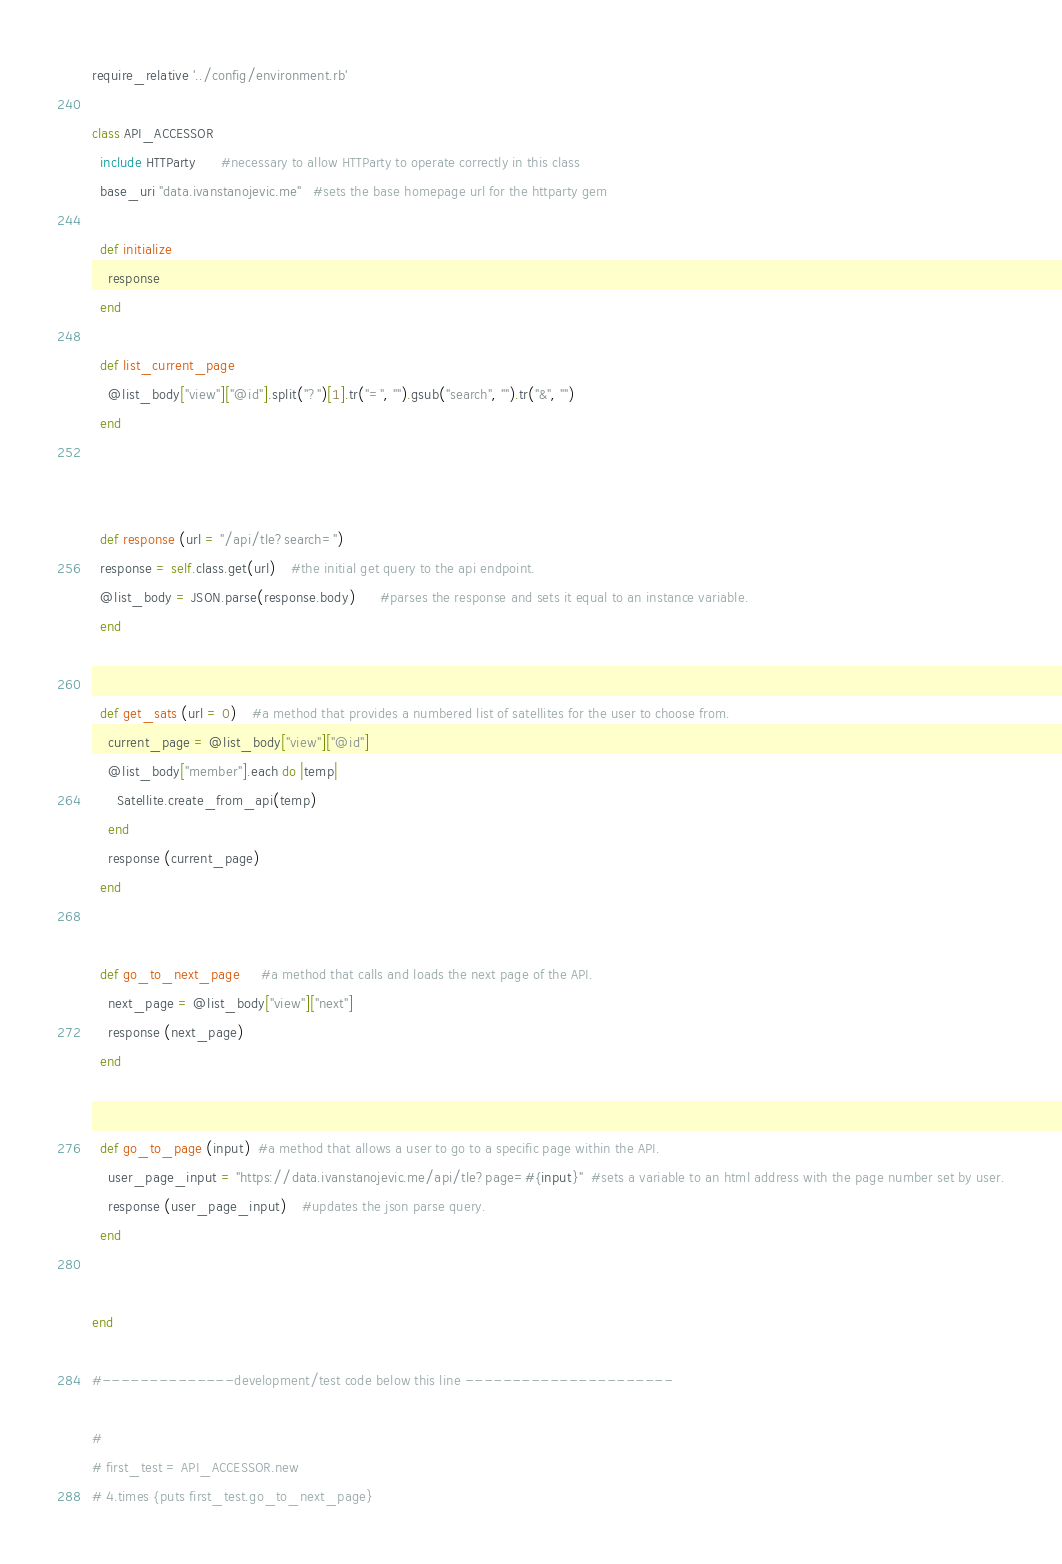Convert code to text. <code><loc_0><loc_0><loc_500><loc_500><_Ruby_>require_relative '../config/environment.rb'

class API_ACCESSOR
  include HTTParty      #necessary to allow HTTParty to operate correctly in this class
  base_uri "data.ivanstanojevic.me"   #sets the base homepage url for the httparty gem

  def initialize
    response
  end

  def list_current_page
    @list_body["view"]["@id"].split("?")[1].tr("=", "").gsub("search", "").tr("&", "")
  end



  def response (url = "/api/tle?search=")
  response = self.class.get(url)    #the initial get query to the api endpoint.
  @list_body = JSON.parse(response.body)      #parses the response and sets it equal to an instance variable.
  end


  def get_sats (url = 0)    #a method that provides a numbered list of satellites for the user to choose from.
    current_page = @list_body["view"]["@id"]
    @list_body["member"].each do |temp|
      Satellite.create_from_api(temp)
    end
    response (current_page)
  end


  def go_to_next_page     #a method that calls and loads the next page of the API.
    next_page = @list_body["view"]["next"]
    response (next_page)
  end


  def go_to_page (input)  #a method that allows a user to go to a specific page within the API.
    user_page_input = "https://data.ivanstanojevic.me/api/tle?page=#{input}"  #sets a variable to an html address with the page number set by user.
    response (user_page_input)    #updates the json parse query.
  end


end

#--------------development/test code below this line ----------------------

#
# first_test = API_ACCESSOR.new
# 4.times {puts first_test.go_to_next_page}
</code> 